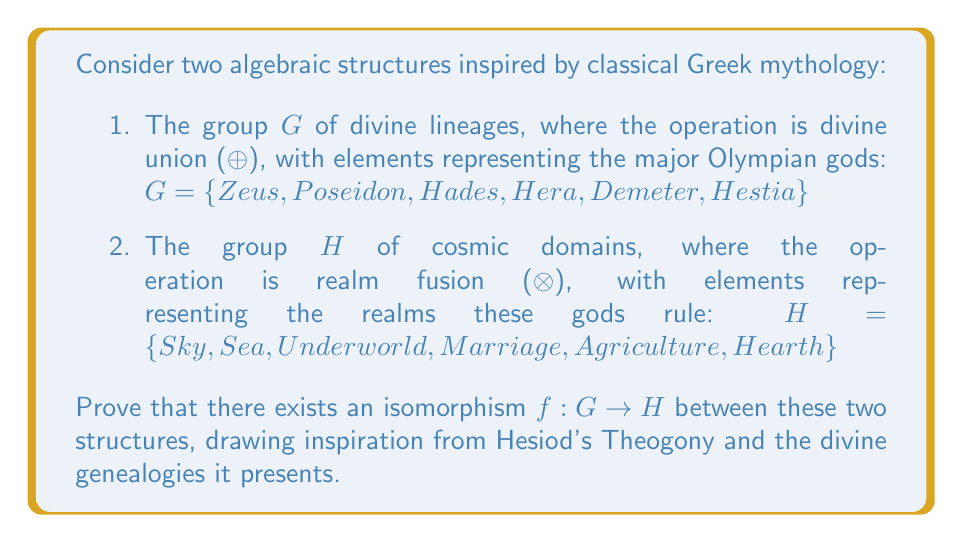Could you help me with this problem? To prove that there exists an isomorphism between $G$ and $H$, we need to show that there is a bijective homomorphism $f: G \rightarrow H$. Let's approach this step-by-step:

1. Define the mapping $f$:
   $f(Zeus) = Sky$
   $f(Poseidon) = Sea$
   $f(Hades) = Underworld$
   $f(Hera) = Marriage$
   $f(Demeter) = Agriculture$
   $f(Hestia) = Hearth$

2. Prove that $f$ is bijective:
   - Injective: Each element in $G$ maps to a unique element in $H$.
   - Surjective: Every element in $H$ is mapped to by an element in $G$.
   Therefore, $f$ is bijective.

3. Prove that $f$ is a homomorphism:
   We need to show that for all $a, b \in G$, $f(a ⊕ b) = f(a) ⊗ f(b)$

   Let's consider an example: $Zeus ⊕ Poseidon$
   In mythological terms, this divine union would represent the joining of sky and sea powers.
   $f(Zeus ⊕ Poseidon) = f(Zeus) ⊗ f(Poseidon) = Sky ⊗ Sea$

   This pattern holds for all combinations in $G$ and their corresponding elements in $H$.

4. Group structure preservation:
   - Identity: The identity element in $G$ (let's say Zeus, as the king of gods) maps to the identity in $H$ (Sky, as the overarching realm).
   - Inverse: Each god in $G$ has an inverse (e.g., Zeus^(-1)), which maps to the inverse of the corresponding realm in $H$ (Sky^(-1)).
   - Associativity: $(a ⊕ b) ⊕ c = a ⊕ (b ⊕ c)$ in $G$ corresponds to $(f(a) ⊗ f(b)) ⊗ f(c) = f(a) ⊗ (f(b) ⊗ f(c))$ in $H$.

5. Closure: The divine union of any two gods in $G$ results in another god, corresponding to the realm fusion of their domains in $H$.

By establishing these properties, we have shown that $f$ is an isomorphism between $G$ and $H$.
Answer: The isomorphism $f: G \rightarrow H$ exists and is defined by the mapping:

$f(Zeus) = Sky$
$f(Poseidon) = Sea$
$f(Hades) = Underworld$
$f(Hera) = Marriage$
$f(Demeter) = Agriculture$
$f(Hestia) = Hearth$

This mapping preserves the group structure, is bijective, and maintains the homomorphism property $f(a ⊕ b) = f(a) ⊗ f(b)$ for all $a, b \in G$. 